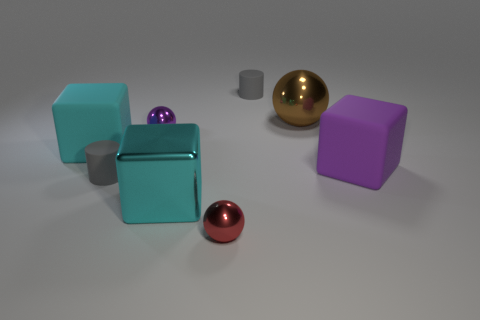Add 2 shiny blocks. How many objects exist? 10 Subtract all spheres. How many objects are left? 5 Subtract 0 yellow spheres. How many objects are left? 8 Subtract all big rubber cylinders. Subtract all cyan matte cubes. How many objects are left? 7 Add 3 brown balls. How many brown balls are left? 4 Add 8 big brown metal spheres. How many big brown metal spheres exist? 9 